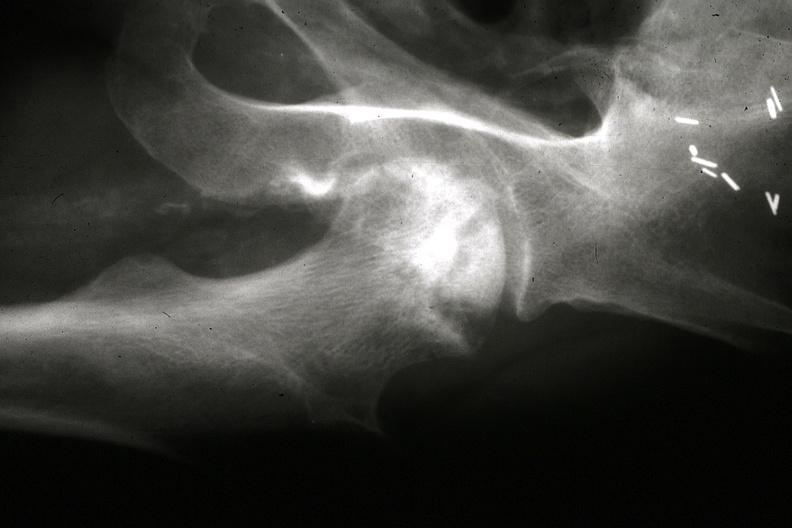what are other x-rays slides?
Answer the question using a single word or phrase. Rays in 